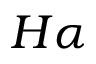<formula> <loc_0><loc_0><loc_500><loc_500>H \alpha</formula> 